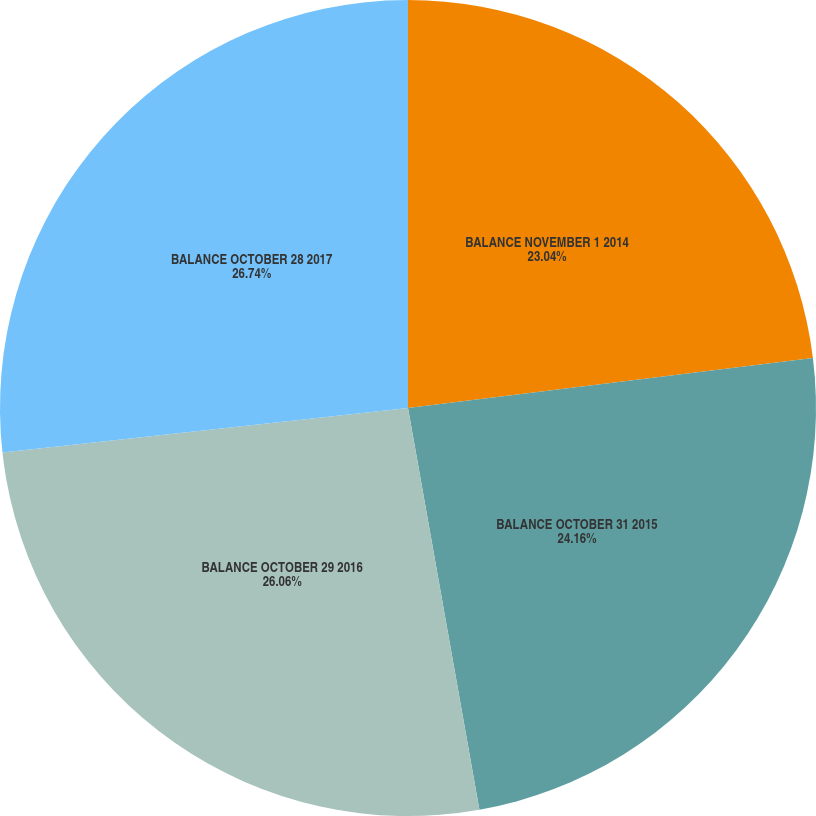Convert chart. <chart><loc_0><loc_0><loc_500><loc_500><pie_chart><fcel>BALANCE NOVEMBER 1 2014<fcel>BALANCE OCTOBER 31 2015<fcel>BALANCE OCTOBER 29 2016<fcel>BALANCE OCTOBER 28 2017<nl><fcel>23.04%<fcel>24.16%<fcel>26.06%<fcel>26.74%<nl></chart> 